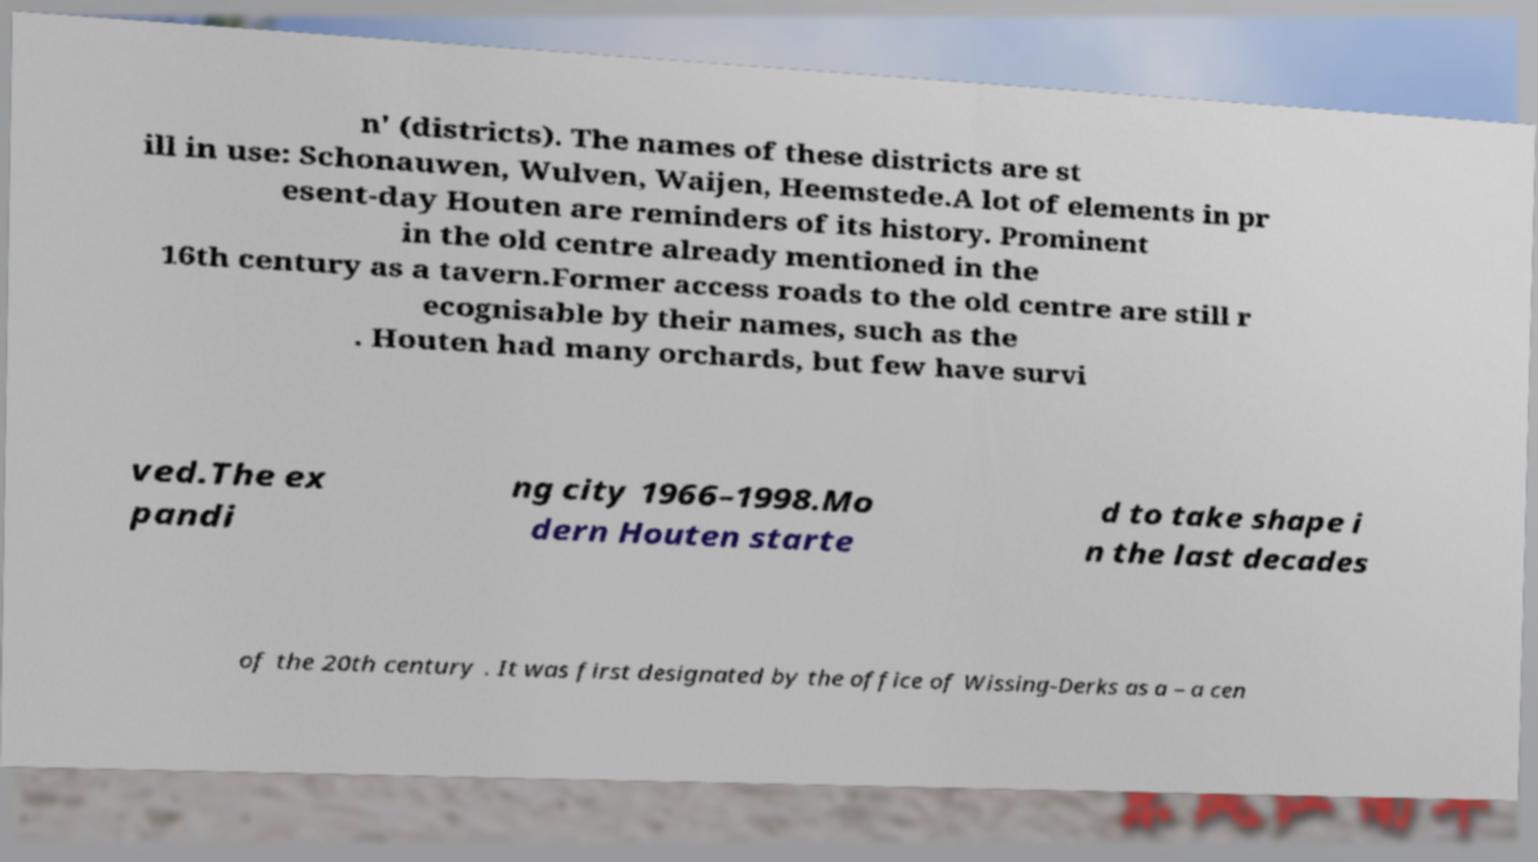Please identify and transcribe the text found in this image. n' (districts). The names of these districts are st ill in use: Schonauwen, Wulven, Waijen, Heemstede.A lot of elements in pr esent-day Houten are reminders of its history. Prominent in the old centre already mentioned in the 16th century as a tavern.Former access roads to the old centre are still r ecognisable by their names, such as the . Houten had many orchards, but few have survi ved.The ex pandi ng city 1966–1998.Mo dern Houten starte d to take shape i n the last decades of the 20th century . It was first designated by the office of Wissing-Derks as a – a cen 